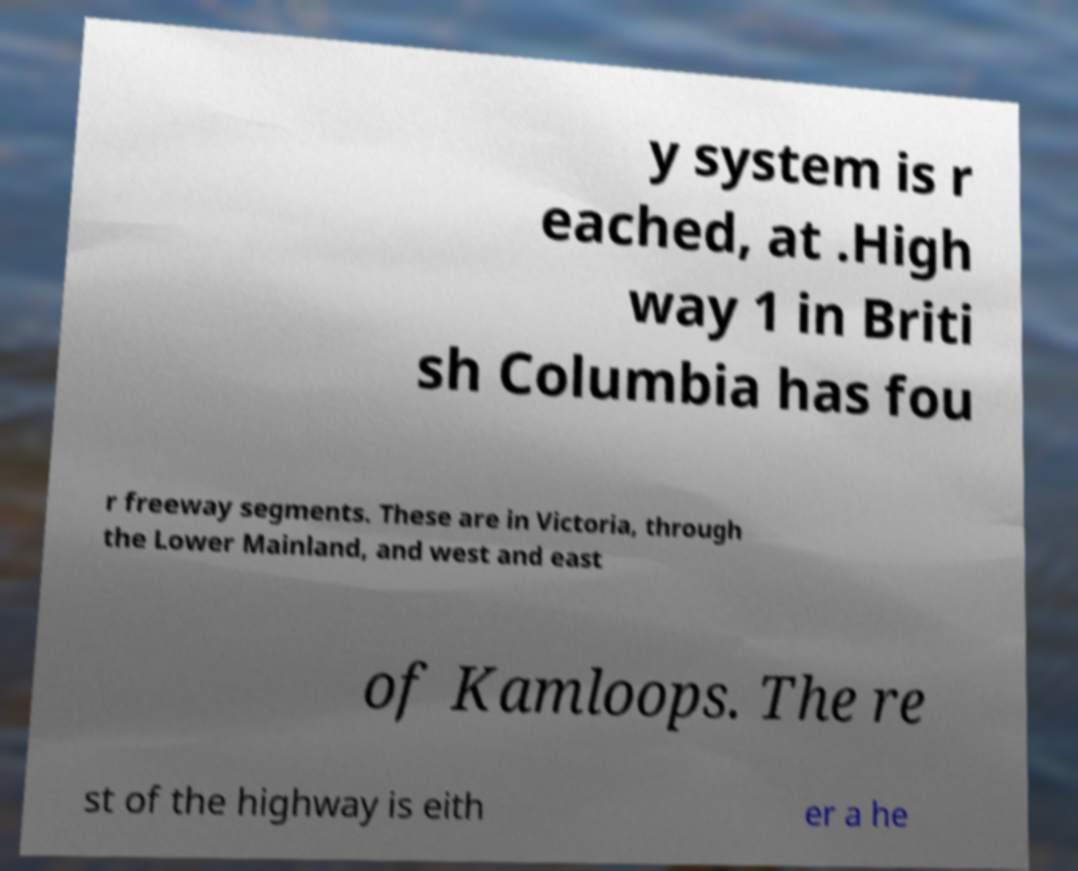Could you extract and type out the text from this image? y system is r eached, at .High way 1 in Briti sh Columbia has fou r freeway segments. These are in Victoria, through the Lower Mainland, and west and east of Kamloops. The re st of the highway is eith er a he 